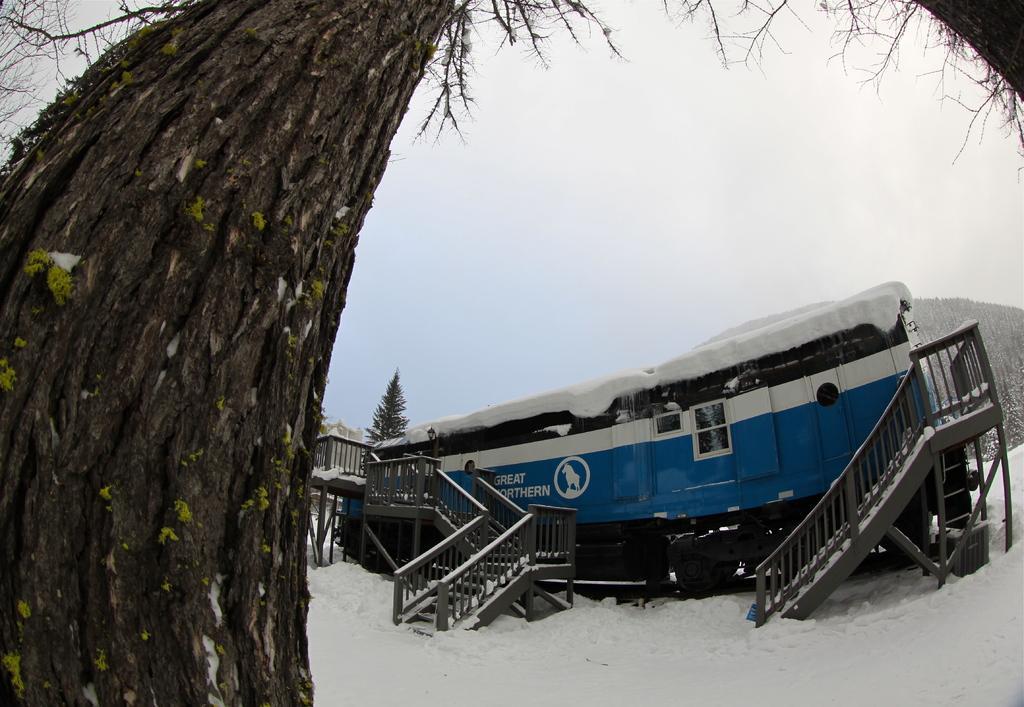How would you summarize this image in a sentence or two? In the center of the image there is a vehicle and we can see trees. There are stairs. At the bottom there is snow. In the background there is sky. 